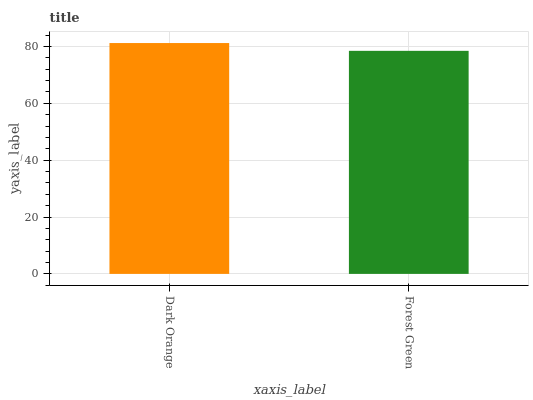Is Forest Green the maximum?
Answer yes or no. No. Is Dark Orange greater than Forest Green?
Answer yes or no. Yes. Is Forest Green less than Dark Orange?
Answer yes or no. Yes. Is Forest Green greater than Dark Orange?
Answer yes or no. No. Is Dark Orange less than Forest Green?
Answer yes or no. No. Is Dark Orange the high median?
Answer yes or no. Yes. Is Forest Green the low median?
Answer yes or no. Yes. Is Forest Green the high median?
Answer yes or no. No. Is Dark Orange the low median?
Answer yes or no. No. 